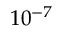Convert formula to latex. <formula><loc_0><loc_0><loc_500><loc_500>1 0 ^ { - 7 }</formula> 